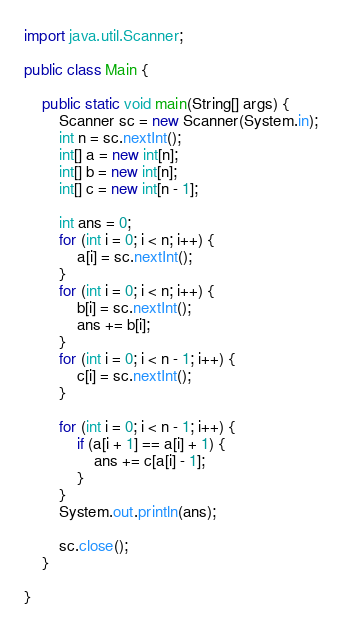<code> <loc_0><loc_0><loc_500><loc_500><_Java_>import java.util.Scanner;

public class Main {

    public static void main(String[] args) {
        Scanner sc = new Scanner(System.in);
        int n = sc.nextInt();
        int[] a = new int[n];
        int[] b = new int[n];
        int[] c = new int[n - 1];

        int ans = 0;
        for (int i = 0; i < n; i++) {
            a[i] = sc.nextInt();
        }
        for (int i = 0; i < n; i++) {
            b[i] = sc.nextInt();
            ans += b[i];
        }
        for (int i = 0; i < n - 1; i++) {
            c[i] = sc.nextInt();
        }

        for (int i = 0; i < n - 1; i++) {
            if (a[i + 1] == a[i] + 1) {
                ans += c[a[i] - 1];
            }
        }
        System.out.println(ans);

        sc.close();
    }

}
</code> 